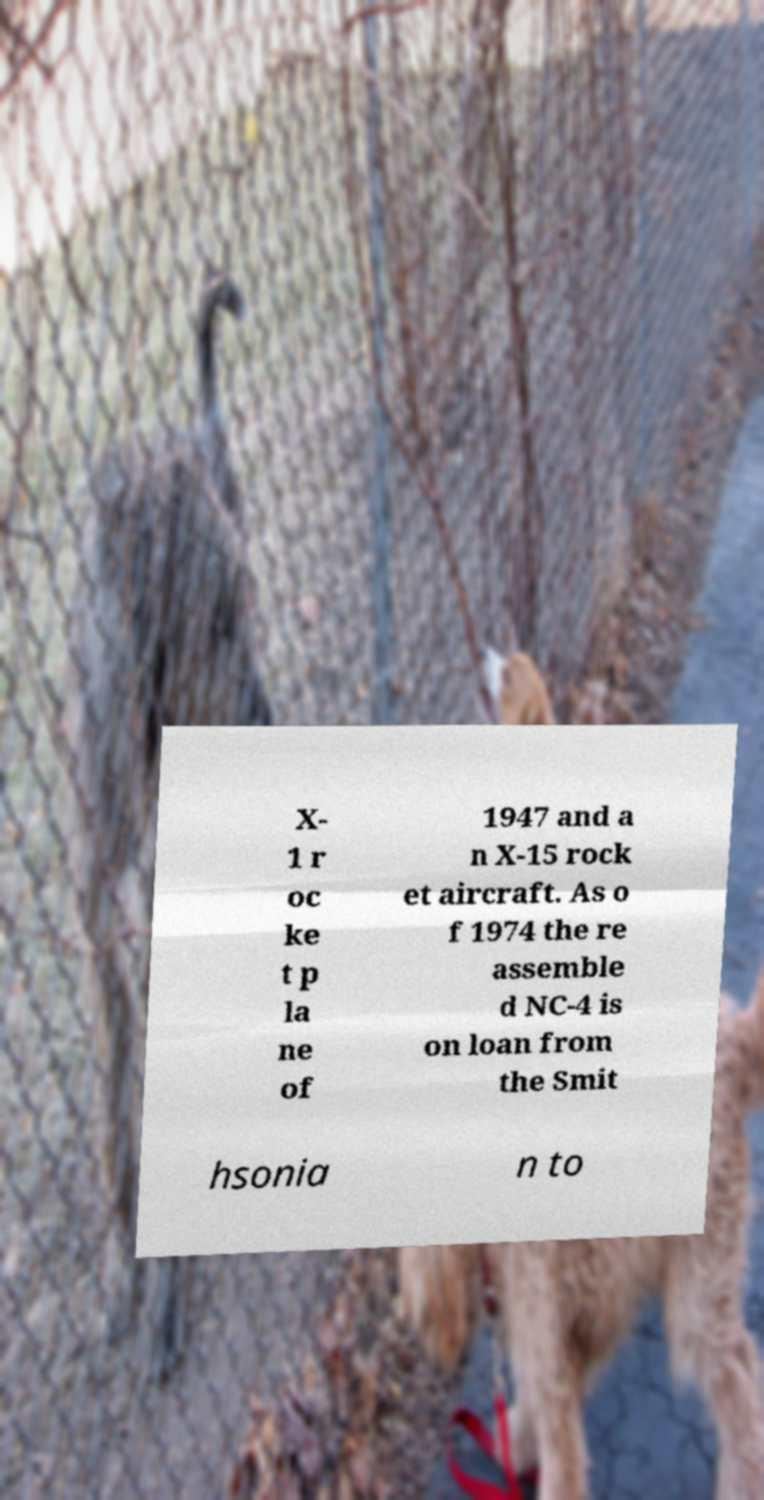Could you assist in decoding the text presented in this image and type it out clearly? X- 1 r oc ke t p la ne of 1947 and a n X-15 rock et aircraft. As o f 1974 the re assemble d NC-4 is on loan from the Smit hsonia n to 